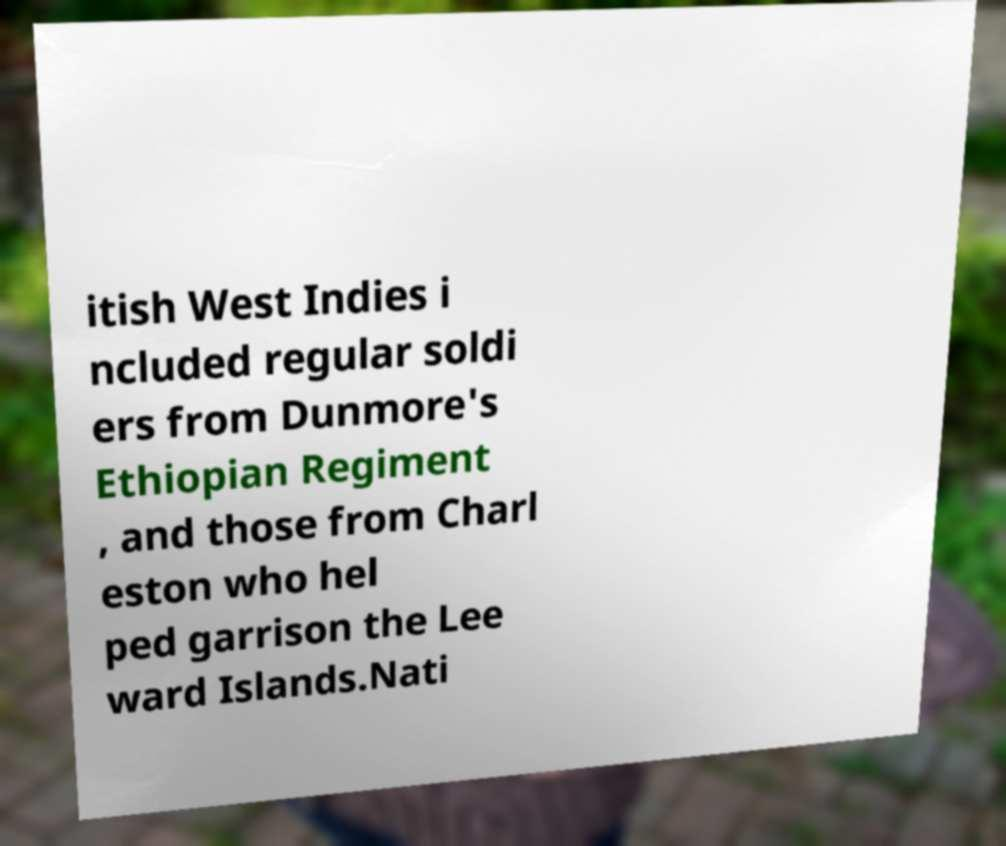Could you extract and type out the text from this image? itish West Indies i ncluded regular soldi ers from Dunmore's Ethiopian Regiment , and those from Charl eston who hel ped garrison the Lee ward Islands.Nati 